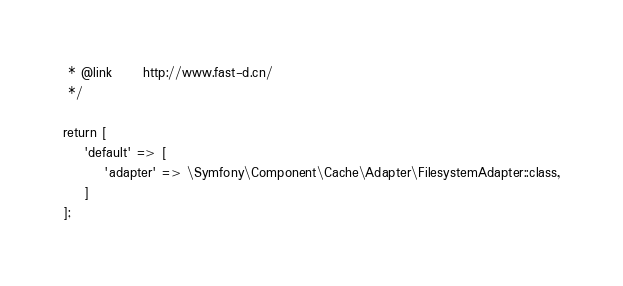Convert code to text. <code><loc_0><loc_0><loc_500><loc_500><_PHP_> * @link      http://www.fast-d.cn/
 */

return [
    'default' => [
        'adapter' => \Symfony\Component\Cache\Adapter\FilesystemAdapter::class,
    ]
];</code> 